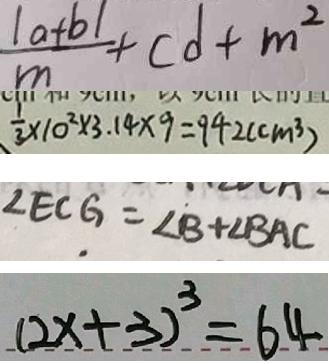<formula> <loc_0><loc_0><loc_500><loc_500>\frac { \vert a + b \vert } { m } + c d + m ^ { 2 } 
 \frac { 1 } { 3 } \times 1 0 ^ { 2 } \times 3 . 1 4 \times 9 = 9 4 2 ( c m ^ { 3 } ) 
 \angle E C G = \angle B + \angle B A C 
 ( 2 x + 3 ) ^ { 3 } = 6 4</formula> 